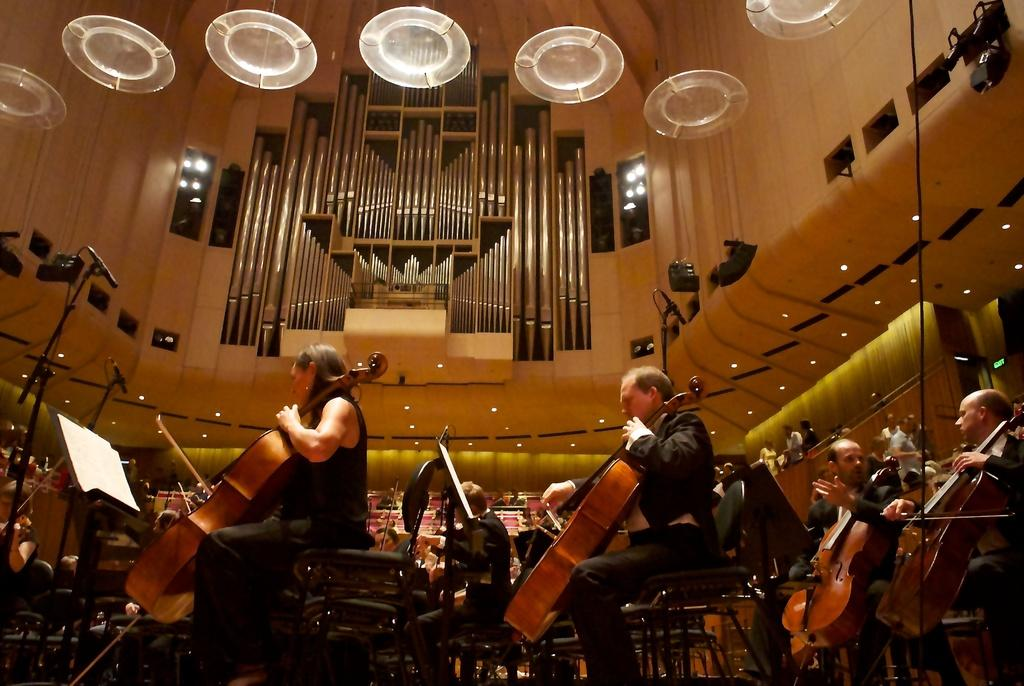What are the people in the image doing? There are many people playing violin in the image. Can you describe the woman on the left side of the image? There is a woman playing violin on the left side of the image. What can be seen in the background of the image? There is a wall, a light, and a microphone (mic) in the background of the image. Are there any other people visible in the image? Yes, there are other people visible in the background of the image. How many books can be seen stacked on the neck of the violin in the image? There are no books visible in the image, let alone stacked on the neck of a violin. 